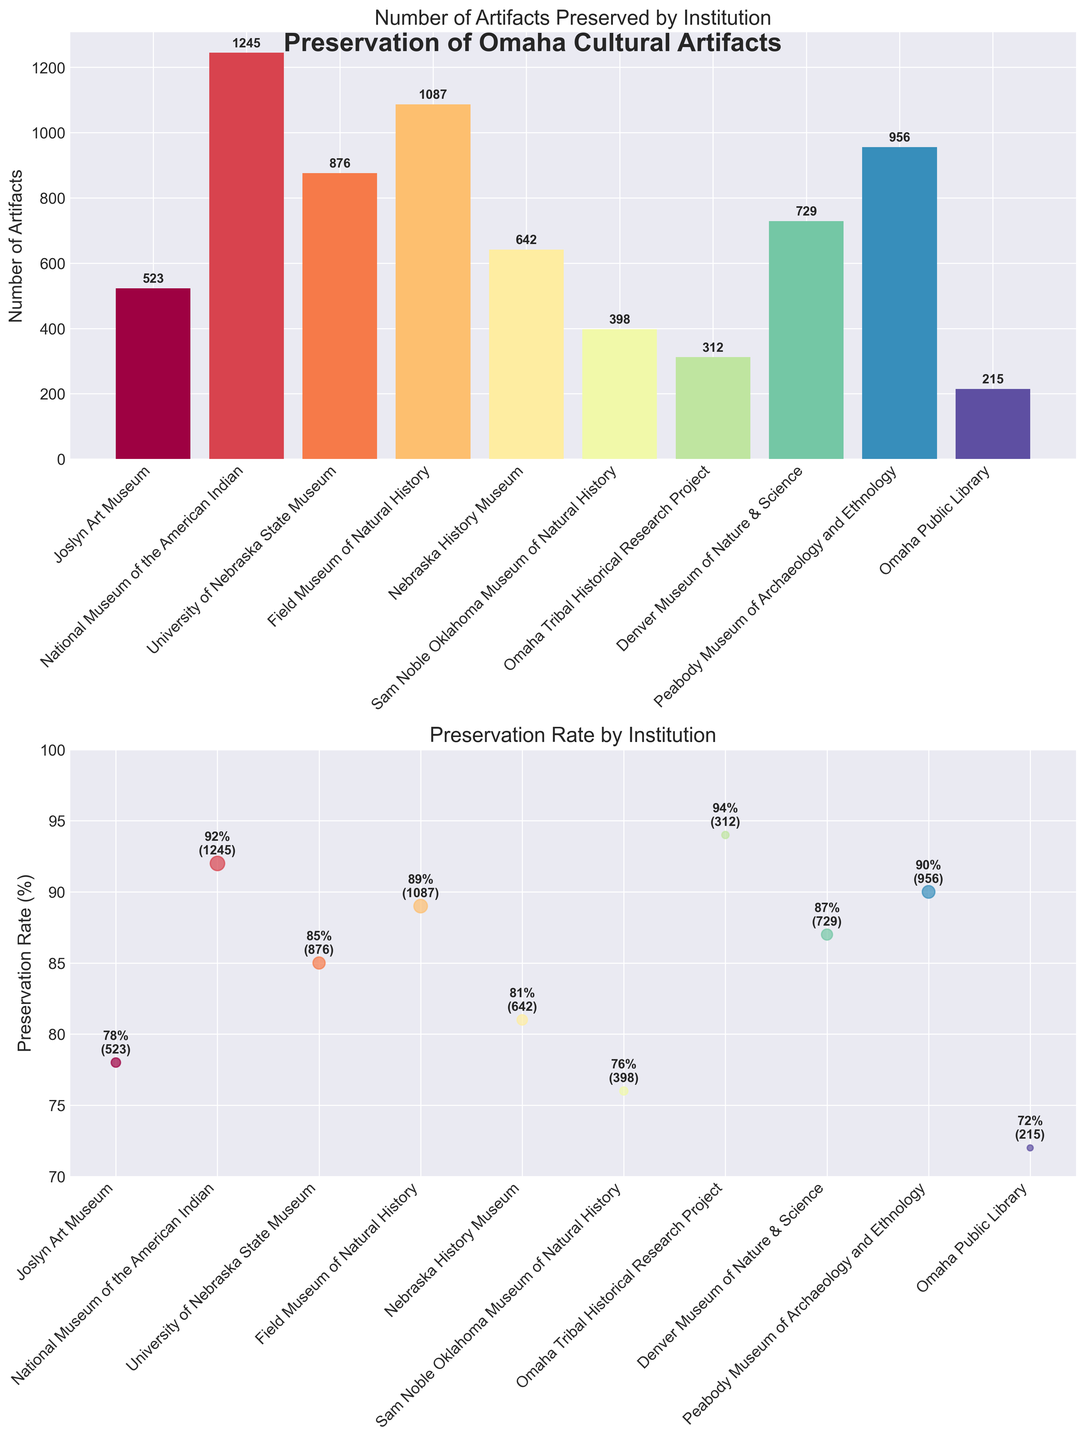what is the title of the bar plot? The title of the bar plot can be found at the top of the first subplot in the figure. It is "Number of Artifacts Preserved by Institution" which indicates what the bar plot represents.
Answer: Number of Artifacts Preserved by Institution how many institutions have a preservation rate above 90%? To find this, look at the scatter plot and identify the preservation rates above 90%. The institutions with such rates are the National Museum of the American Indian, Peabody Museum of Archaeology and Ethnology, and the Omaha Tribal Historical Research Project.
Answer: 3 institutions what institution preserves the most artifacts? Refer to the tallest bar in the bar plot. The institution with the highest bar is the National Museum of the American Indian with 1245 artifacts preserved.
Answer: National Museum of the American Indian which institution has the lowest preservation rate? Look at the scatter plot and find the lowest point on the y-axis (preservation rate). The Omaha Public Library has the lowest preservation rate (72%).
Answer: Omaha Public Library what is the total number of artifacts preserved by all institutions combined? Sum the numbers from the bar plot: 523 + 1245 + 876 + 1087 + 642 + 398 + 312 + 729 + 956 + 215 = 6983.
Answer: 6983 which institutions have both preservation rates above 85% and more than 800 artifacts preserved? Find points above 85% on the scatter plot and corresponding bars in the bar plot. These institutions are National Museum of the American Indian (1245 artifacts, 92%), University of Nebraska State Museum (876 artifacts, 85%), Field Museum of Natural History (1087 artifacts, 89%), and Peabody Museum of Archaeology and Ethnology (956 artifacts, 90%).
Answer: National Museum of the American Indian, University of Nebraska State Museum, Field Museum of Natural History, Peabody Museum of Archaeology and Ethnology what is the preservation rate of the Denver Museum of Nature & Science? Find the point labeled "Denver Museum of Nature & Science" on the scatter plot. The rate is 87%.
Answer: 87% compare the number of artifacts preserved by the University of Nebraska State Museum and Nebraska History Museum. Which has more and by how many? Look at the bar plot. The University of Nebraska State Museum preserves 876 artifacts, while the Nebraska History Museum preserves 642 artifacts. The difference is: 876 - 642 = 234.
Answer: University of Nebraska State Museum, by 234 artifacts how does the preservation rate of the Peabody Museum of Archaeology and Ethnology compare to that of the Field Museum of Natural History? Check the heights of both points on the scatter plot. The Peabody Museum of Archaeology and Ethnology has a preservation rate of 90%, while the Field Museum of Natural History has 89%. So, the Peabody Museum of Archaeology and Ethnology has a slightly higher rate by 1%.
Answer: Peabody Museum of Archaeology and Ethnology, by 1% 